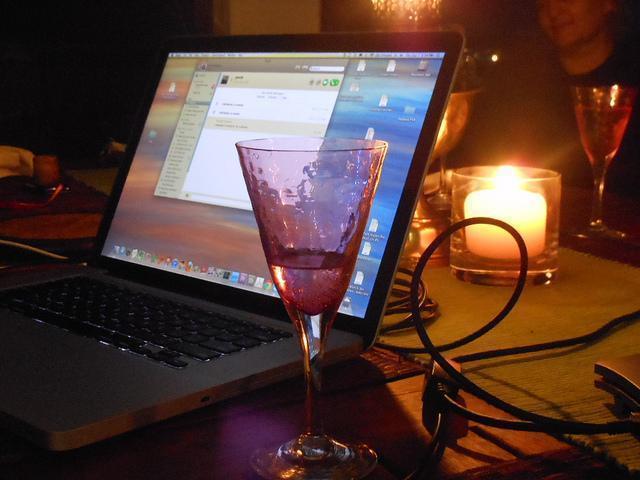What country most frequently uses wine glasses this shape?
Select the accurate answer and provide justification: `Answer: choice
Rationale: srationale.`
Options: Japan, china, usa, france. Answer: france.
Rationale: This glass is used greatly in france. 